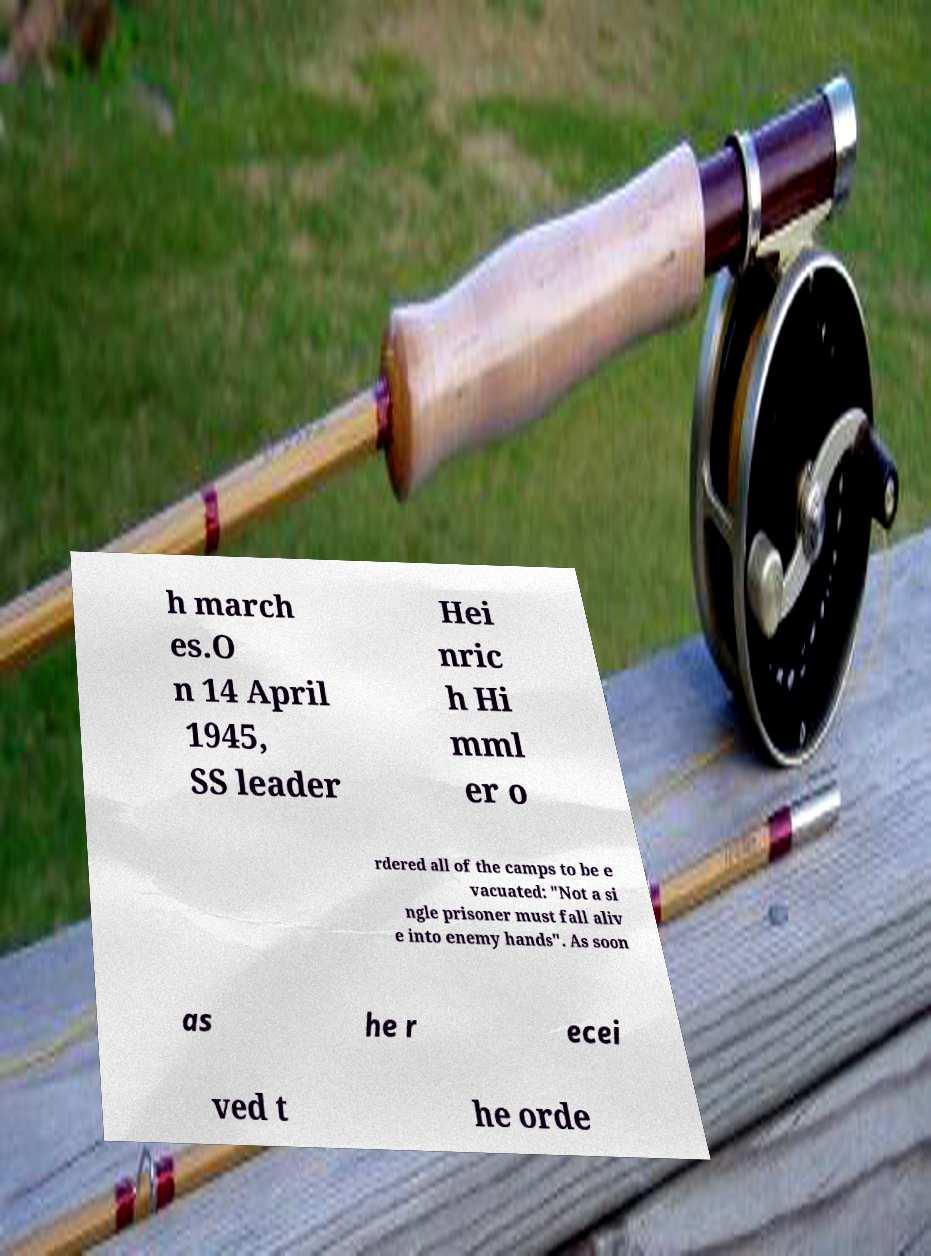Could you extract and type out the text from this image? h march es.O n 14 April 1945, SS leader Hei nric h Hi mml er o rdered all of the camps to be e vacuated: "Not a si ngle prisoner must fall aliv e into enemy hands". As soon as he r ecei ved t he orde 